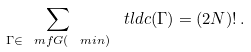Convert formula to latex. <formula><loc_0><loc_0><loc_500><loc_500>\sum _ { \Gamma \in \ m f { G } ( \ m i { n } ) } \ t l d { c } ( \Gamma ) = ( 2 N ) ! \, .</formula> 